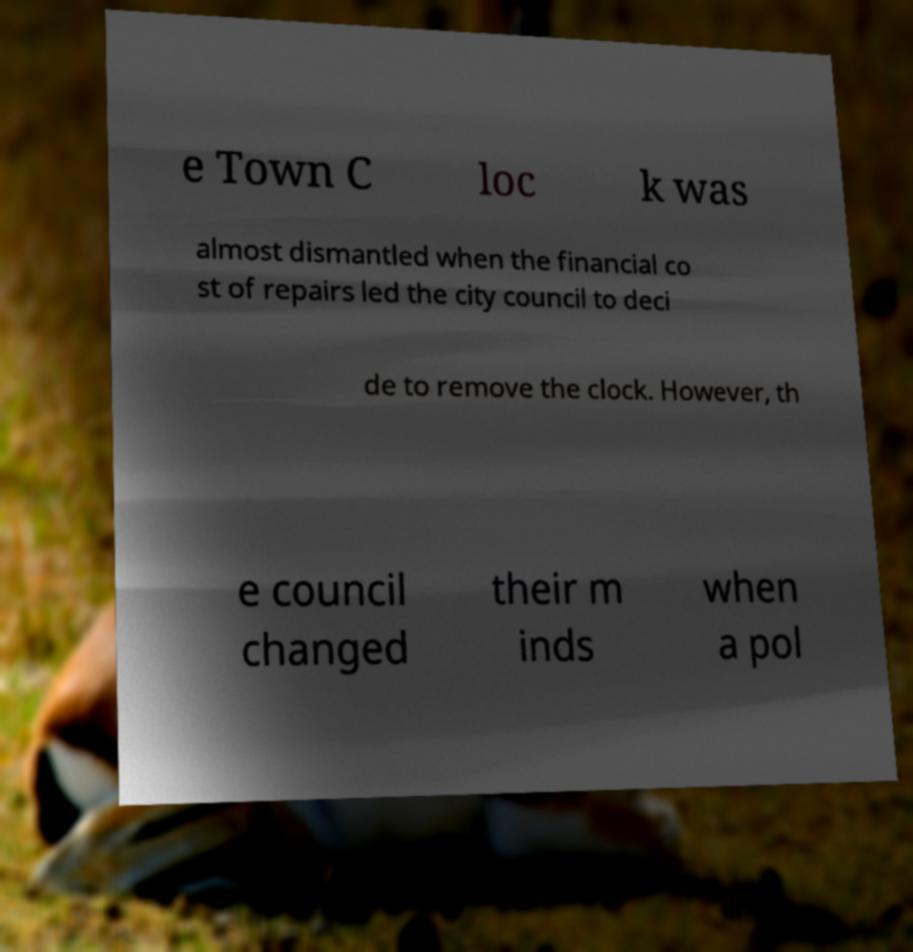Could you extract and type out the text from this image? e Town C loc k was almost dismantled when the financial co st of repairs led the city council to deci de to remove the clock. However, th e council changed their m inds when a pol 